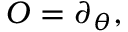<formula> <loc_0><loc_0><loc_500><loc_500>O = \partial _ { \theta } ,</formula> 